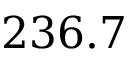Convert formula to latex. <formula><loc_0><loc_0><loc_500><loc_500>2 3 6 . 7</formula> 